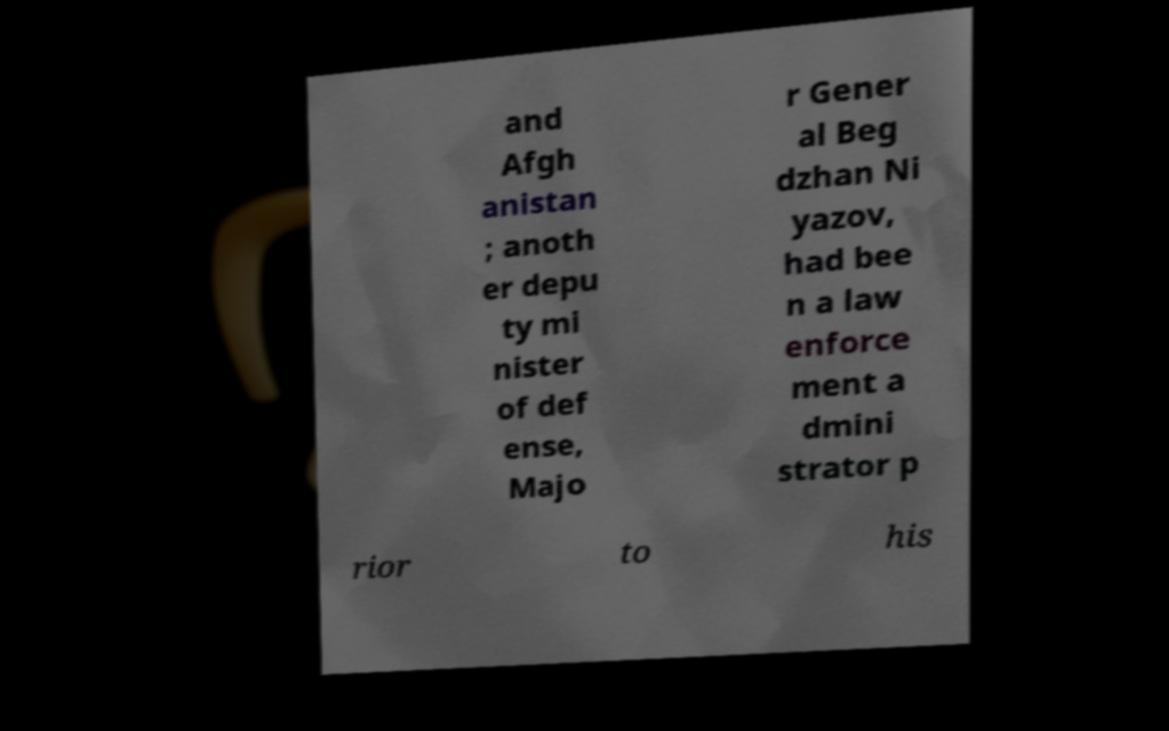I need the written content from this picture converted into text. Can you do that? and Afgh anistan ; anoth er depu ty mi nister of def ense, Majo r Gener al Beg dzhan Ni yazov, had bee n a law enforce ment a dmini strator p rior to his 